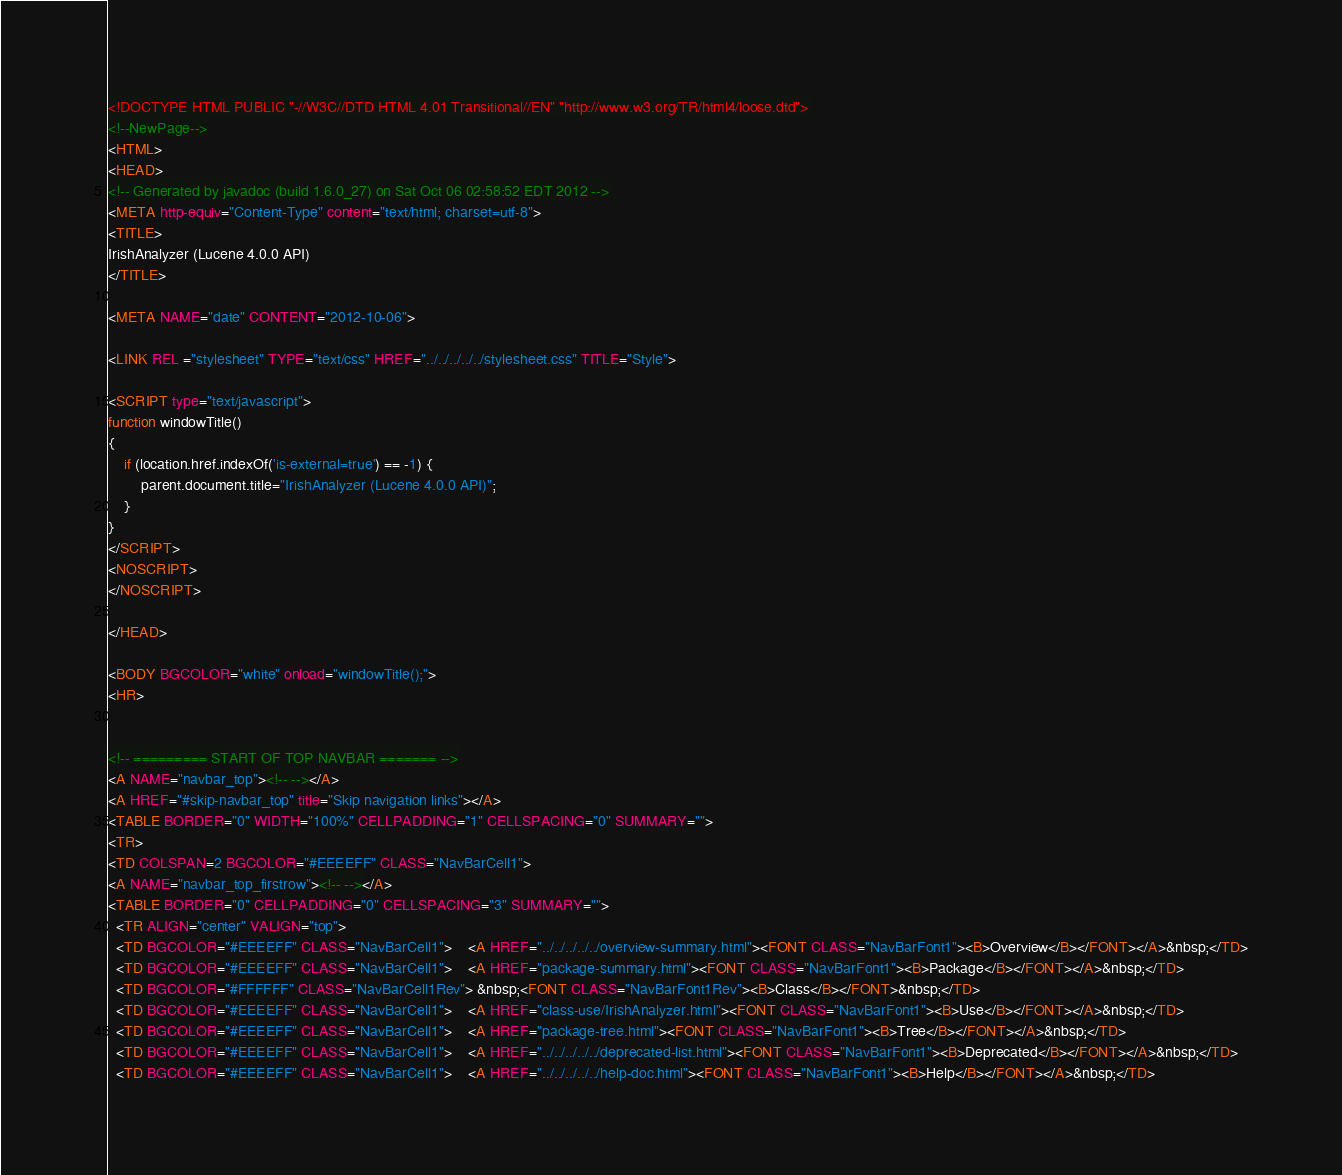Convert code to text. <code><loc_0><loc_0><loc_500><loc_500><_HTML_><!DOCTYPE HTML PUBLIC "-//W3C//DTD HTML 4.01 Transitional//EN" "http://www.w3.org/TR/html4/loose.dtd">
<!--NewPage-->
<HTML>
<HEAD>
<!-- Generated by javadoc (build 1.6.0_27) on Sat Oct 06 02:58:52 EDT 2012 -->
<META http-equiv="Content-Type" content="text/html; charset=utf-8">
<TITLE>
IrishAnalyzer (Lucene 4.0.0 API)
</TITLE>

<META NAME="date" CONTENT="2012-10-06">

<LINK REL ="stylesheet" TYPE="text/css" HREF="../../../../../stylesheet.css" TITLE="Style">

<SCRIPT type="text/javascript">
function windowTitle()
{
    if (location.href.indexOf('is-external=true') == -1) {
        parent.document.title="IrishAnalyzer (Lucene 4.0.0 API)";
    }
}
</SCRIPT>
<NOSCRIPT>
</NOSCRIPT>

</HEAD>

<BODY BGCOLOR="white" onload="windowTitle();">
<HR>


<!-- ========= START OF TOP NAVBAR ======= -->
<A NAME="navbar_top"><!-- --></A>
<A HREF="#skip-navbar_top" title="Skip navigation links"></A>
<TABLE BORDER="0" WIDTH="100%" CELLPADDING="1" CELLSPACING="0" SUMMARY="">
<TR>
<TD COLSPAN=2 BGCOLOR="#EEEEFF" CLASS="NavBarCell1">
<A NAME="navbar_top_firstrow"><!-- --></A>
<TABLE BORDER="0" CELLPADDING="0" CELLSPACING="3" SUMMARY="">
  <TR ALIGN="center" VALIGN="top">
  <TD BGCOLOR="#EEEEFF" CLASS="NavBarCell1">    <A HREF="../../../../../overview-summary.html"><FONT CLASS="NavBarFont1"><B>Overview</B></FONT></A>&nbsp;</TD>
  <TD BGCOLOR="#EEEEFF" CLASS="NavBarCell1">    <A HREF="package-summary.html"><FONT CLASS="NavBarFont1"><B>Package</B></FONT></A>&nbsp;</TD>
  <TD BGCOLOR="#FFFFFF" CLASS="NavBarCell1Rev"> &nbsp;<FONT CLASS="NavBarFont1Rev"><B>Class</B></FONT>&nbsp;</TD>
  <TD BGCOLOR="#EEEEFF" CLASS="NavBarCell1">    <A HREF="class-use/IrishAnalyzer.html"><FONT CLASS="NavBarFont1"><B>Use</B></FONT></A>&nbsp;</TD>
  <TD BGCOLOR="#EEEEFF" CLASS="NavBarCell1">    <A HREF="package-tree.html"><FONT CLASS="NavBarFont1"><B>Tree</B></FONT></A>&nbsp;</TD>
  <TD BGCOLOR="#EEEEFF" CLASS="NavBarCell1">    <A HREF="../../../../../deprecated-list.html"><FONT CLASS="NavBarFont1"><B>Deprecated</B></FONT></A>&nbsp;</TD>
  <TD BGCOLOR="#EEEEFF" CLASS="NavBarCell1">    <A HREF="../../../../../help-doc.html"><FONT CLASS="NavBarFont1"><B>Help</B></FONT></A>&nbsp;</TD></code> 